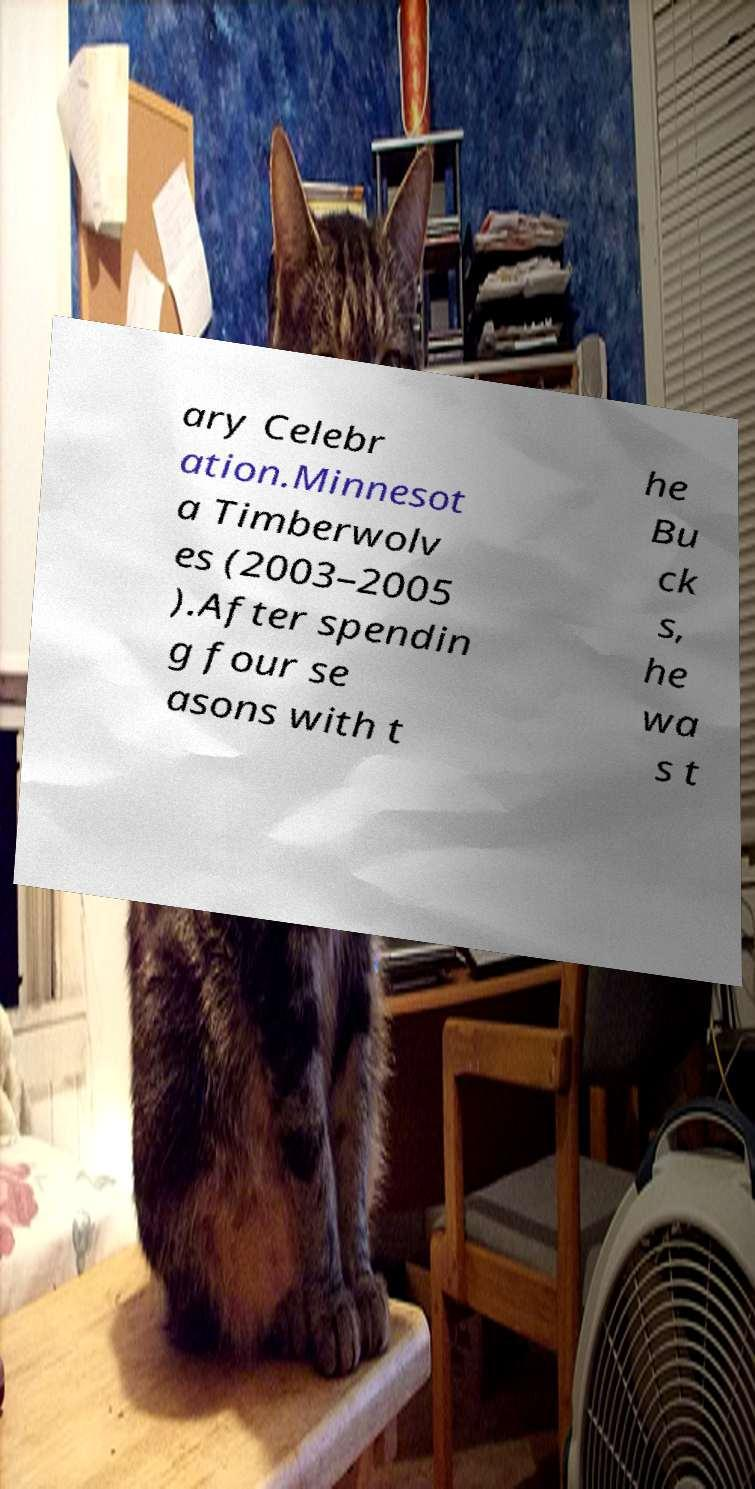There's text embedded in this image that I need extracted. Can you transcribe it verbatim? ary Celebr ation.Minnesot a Timberwolv es (2003–2005 ).After spendin g four se asons with t he Bu ck s, he wa s t 